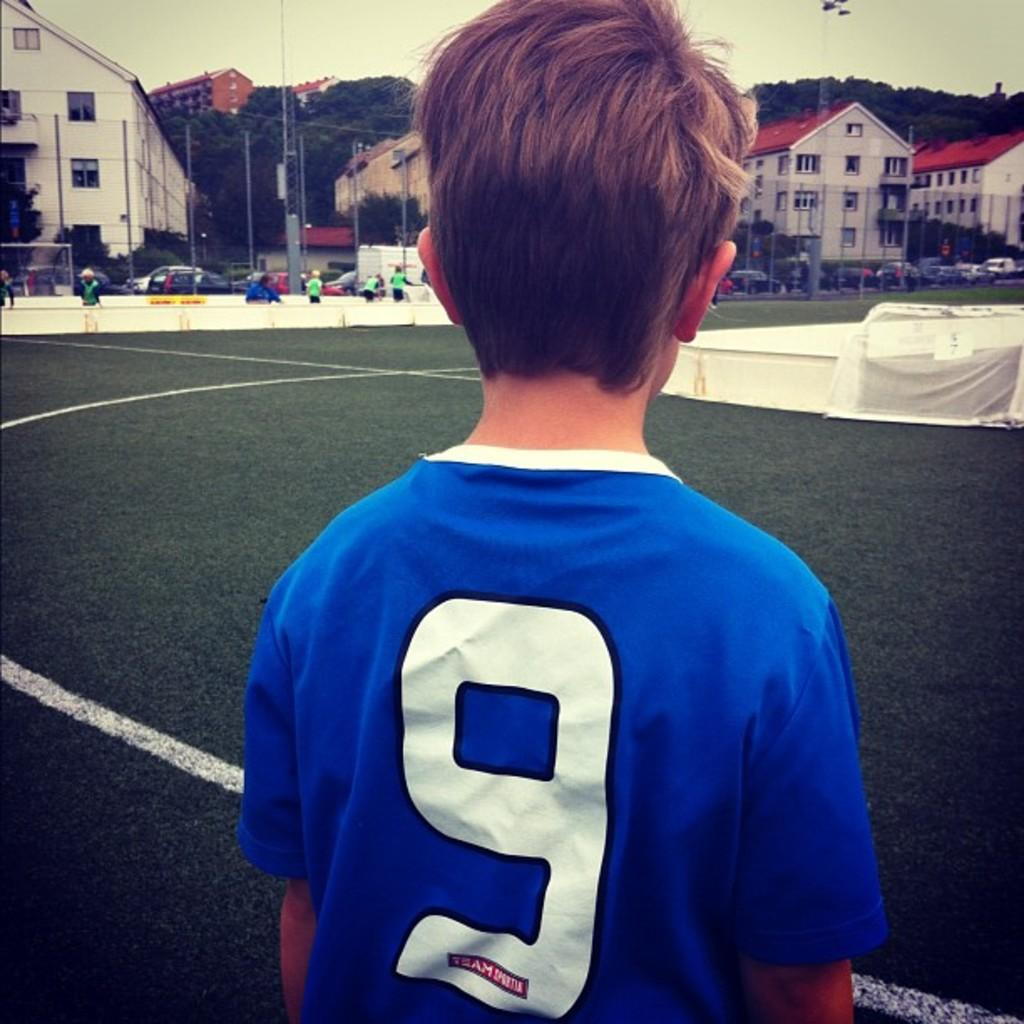Who is the main subject in the image? There is a boy in the image. What is the boy wearing? The boy is wearing a blue t-shirt. What is the boy doing in the image? The boy is standing and looking at a football ground. What can be seen in the foreground of the image? There is a fencing grill in the image. What type of buildings can be seen in the background? There are roof top houses visible in the background. What type of drug is the boy holding in the image? There is no drug present in the image; the boy is simply looking at a football ground. 